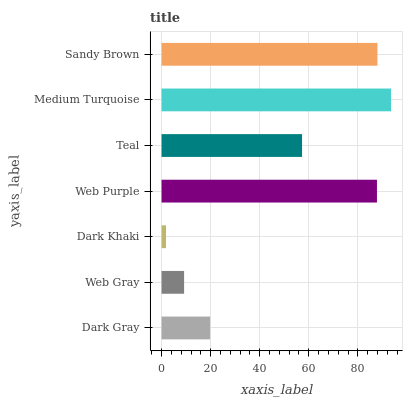Is Dark Khaki the minimum?
Answer yes or no. Yes. Is Medium Turquoise the maximum?
Answer yes or no. Yes. Is Web Gray the minimum?
Answer yes or no. No. Is Web Gray the maximum?
Answer yes or no. No. Is Dark Gray greater than Web Gray?
Answer yes or no. Yes. Is Web Gray less than Dark Gray?
Answer yes or no. Yes. Is Web Gray greater than Dark Gray?
Answer yes or no. No. Is Dark Gray less than Web Gray?
Answer yes or no. No. Is Teal the high median?
Answer yes or no. Yes. Is Teal the low median?
Answer yes or no. Yes. Is Sandy Brown the high median?
Answer yes or no. No. Is Sandy Brown the low median?
Answer yes or no. No. 